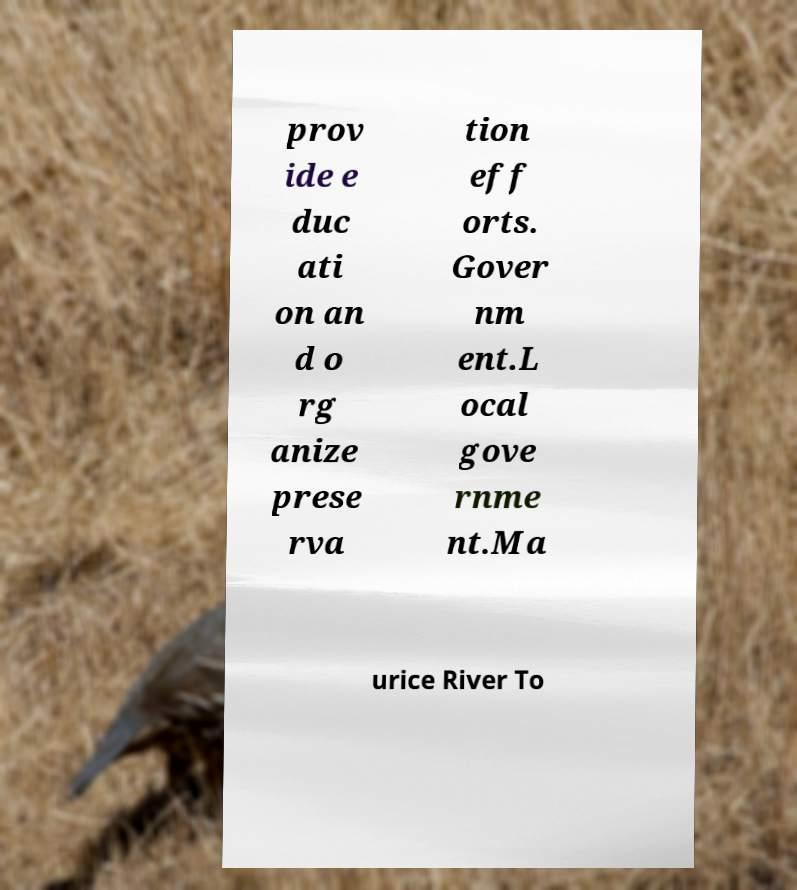I need the written content from this picture converted into text. Can you do that? prov ide e duc ati on an d o rg anize prese rva tion eff orts. Gover nm ent.L ocal gove rnme nt.Ma urice River To 